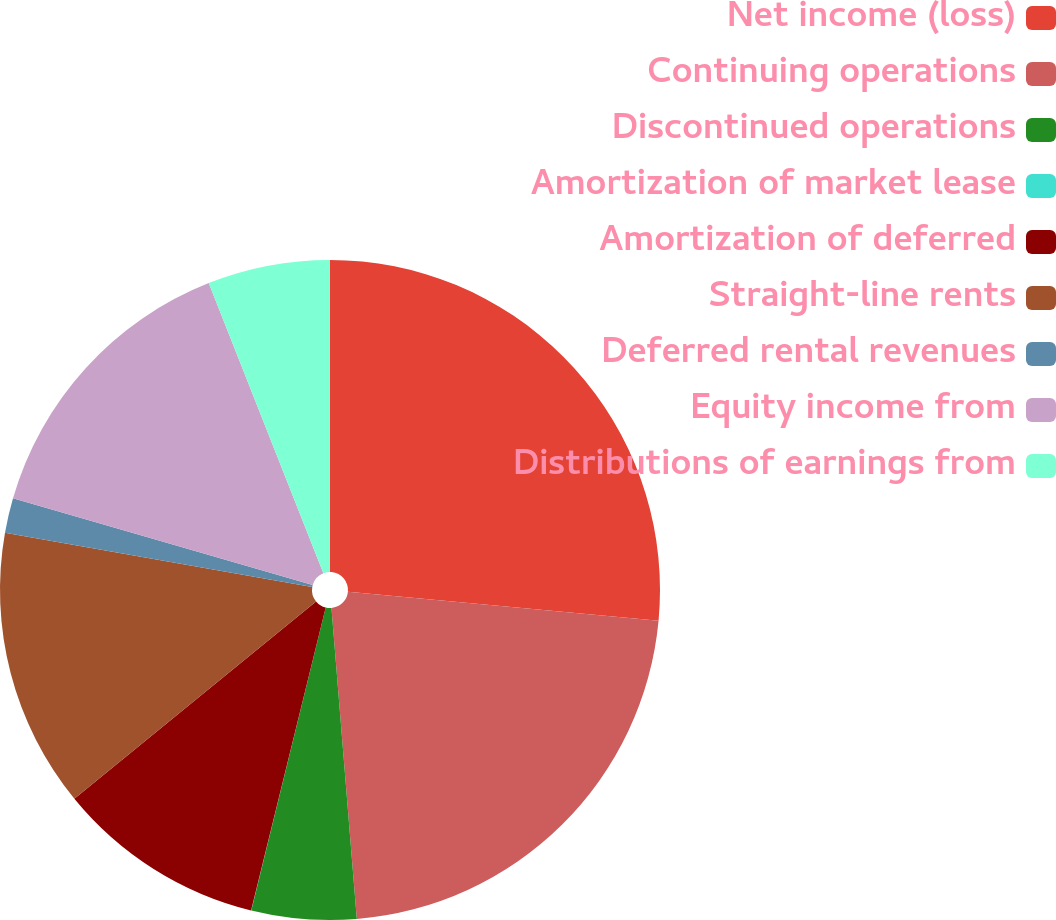Convert chart to OTSL. <chart><loc_0><loc_0><loc_500><loc_500><pie_chart><fcel>Net income (loss)<fcel>Continuing operations<fcel>Discontinued operations<fcel>Amortization of market lease<fcel>Amortization of deferred<fcel>Straight-line rents<fcel>Deferred rental revenues<fcel>Equity income from<fcel>Distributions of earnings from<nl><fcel>26.49%<fcel>22.22%<fcel>5.13%<fcel>0.01%<fcel>10.26%<fcel>13.67%<fcel>1.71%<fcel>14.53%<fcel>5.99%<nl></chart> 